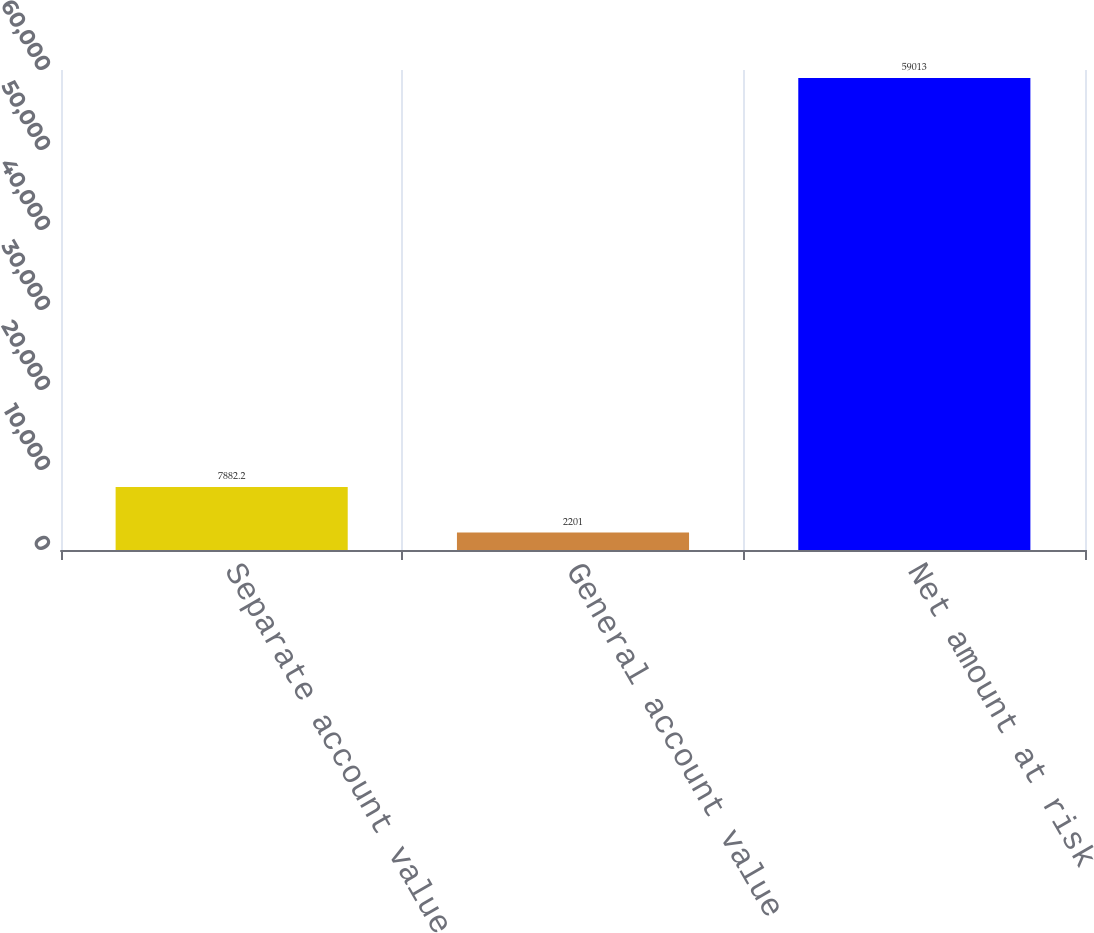<chart> <loc_0><loc_0><loc_500><loc_500><bar_chart><fcel>Separate account value<fcel>General account value<fcel>Net amount at risk<nl><fcel>7882.2<fcel>2201<fcel>59013<nl></chart> 